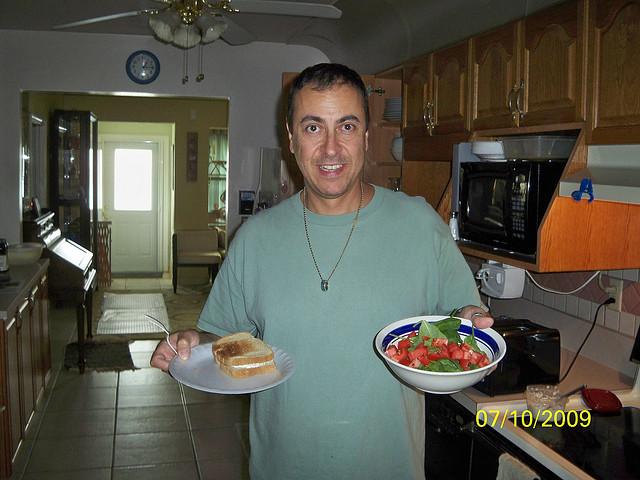What is the man holding in his hands?
Short answer required. Salad and sandwich. How many bowls have food in them?
Be succinct. 1. What time of day is it?
Concise answer only. Afternoon. What is in the bowl?
Give a very brief answer. Salad. 